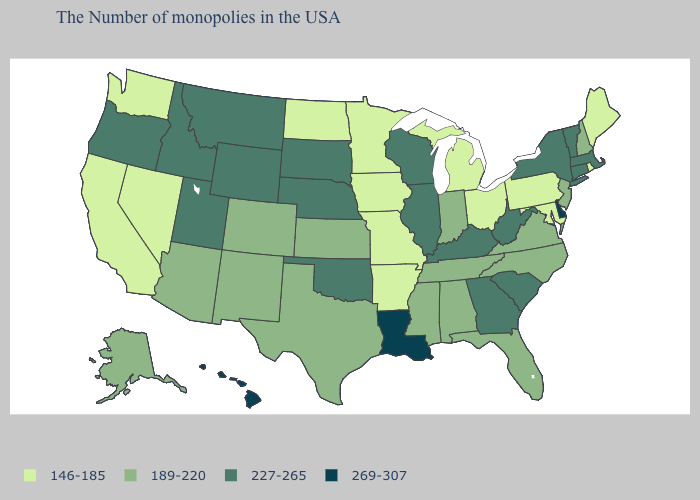Does Missouri have the highest value in the USA?
Write a very short answer. No. What is the value of Texas?
Be succinct. 189-220. What is the value of Pennsylvania?
Write a very short answer. 146-185. Which states have the highest value in the USA?
Short answer required. Delaware, Louisiana, Hawaii. Which states have the highest value in the USA?
Quick response, please. Delaware, Louisiana, Hawaii. Among the states that border Georgia , which have the lowest value?
Give a very brief answer. North Carolina, Florida, Alabama, Tennessee. Is the legend a continuous bar?
Short answer required. No. What is the value of Minnesota?
Write a very short answer. 146-185. Does Michigan have the lowest value in the USA?
Keep it brief. Yes. Is the legend a continuous bar?
Quick response, please. No. Among the states that border Kentucky , does Indiana have the highest value?
Keep it brief. No. Among the states that border Pennsylvania , which have the lowest value?
Short answer required. Maryland, Ohio. What is the value of Alaska?
Short answer required. 189-220. Which states have the lowest value in the West?
Give a very brief answer. Nevada, California, Washington. Name the states that have a value in the range 227-265?
Keep it brief. Massachusetts, Vermont, Connecticut, New York, South Carolina, West Virginia, Georgia, Kentucky, Wisconsin, Illinois, Nebraska, Oklahoma, South Dakota, Wyoming, Utah, Montana, Idaho, Oregon. 